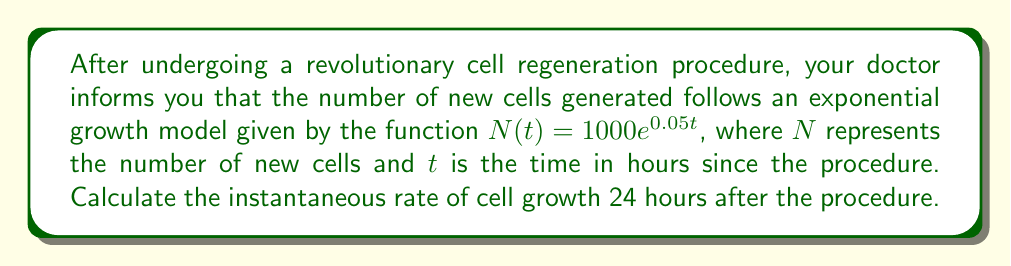Give your solution to this math problem. To find the instantaneous rate of cell growth, we need to calculate the derivative of the given function at $t = 24$ hours. Let's approach this step-by-step:

1) The given function is $N(t) = 1000e^{0.05t}$

2) To find the rate of change, we need to differentiate $N(t)$ with respect to $t$:

   $$\frac{dN}{dt} = 1000 \cdot 0.05 \cdot e^{0.05t} = 50e^{0.05t}$$

3) This derivative represents the instantaneous rate of cell growth at any time $t$.

4) To find the rate at 24 hours after the procedure, we substitute $t = 24$ into our derivative:

   $$\frac{dN}{dt}\bigg|_{t=24} = 50e^{0.05(24)} = 50e^{1.2}$$

5) Calculate the value:
   
   $$50e^{1.2} \approx 165.73$$

Therefore, 24 hours after the procedure, cells are being generated at a rate of approximately 165.73 cells per hour.
Answer: The instantaneous rate of cell growth 24 hours after the procedure is approximately 165.73 cells per hour. 